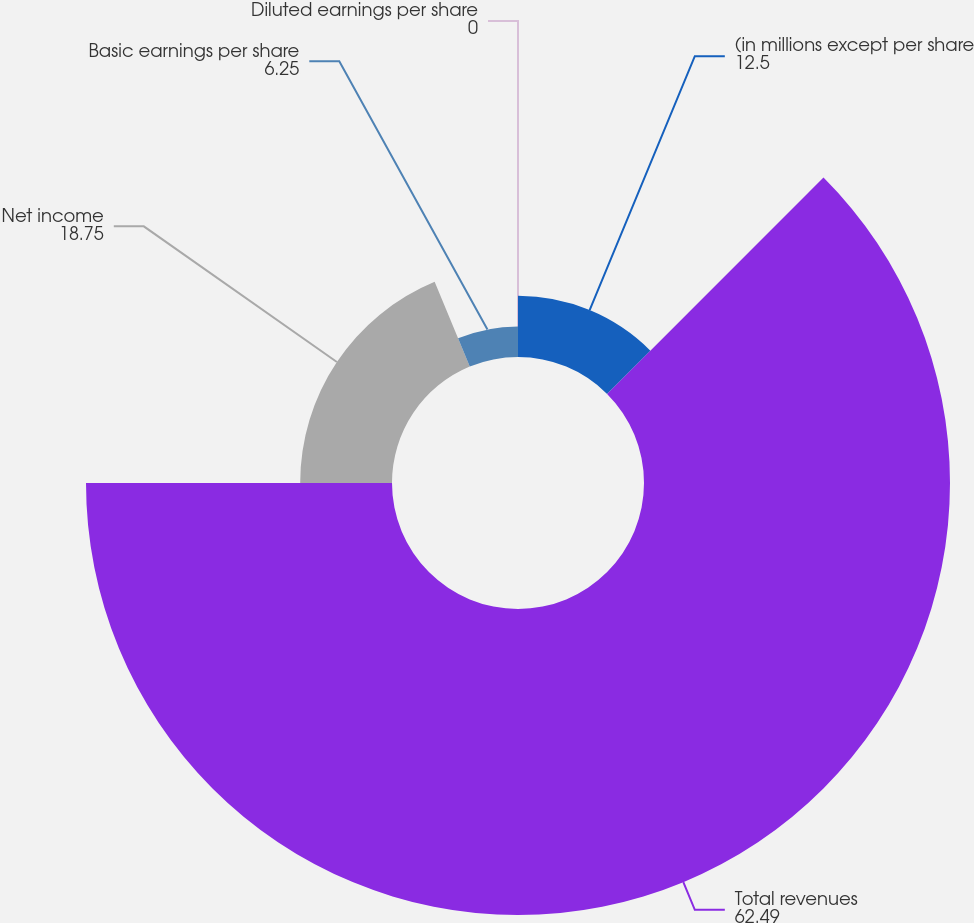Convert chart to OTSL. <chart><loc_0><loc_0><loc_500><loc_500><pie_chart><fcel>(in millions except per share<fcel>Total revenues<fcel>Net income<fcel>Basic earnings per share<fcel>Diluted earnings per share<nl><fcel>12.5%<fcel>62.49%<fcel>18.75%<fcel>6.25%<fcel>0.0%<nl></chart> 